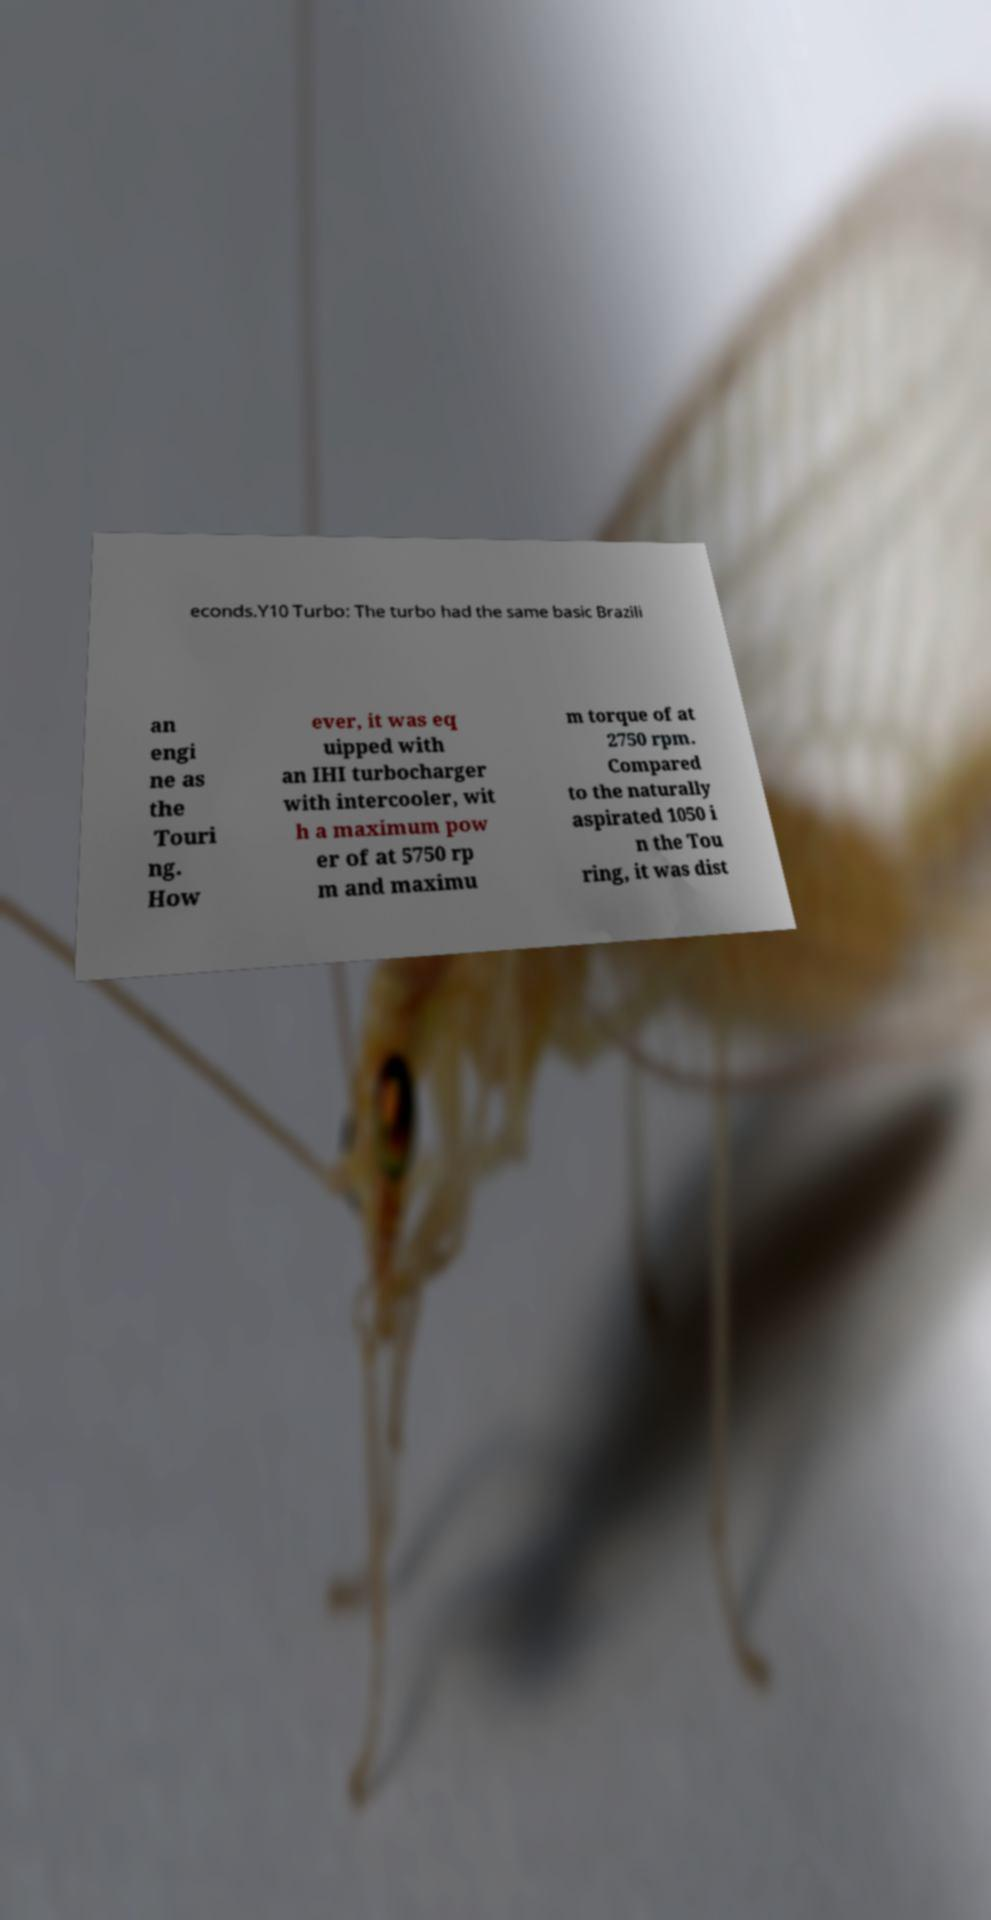Please read and relay the text visible in this image. What does it say? econds.Y10 Turbo: The turbo had the same basic Brazili an engi ne as the Touri ng. How ever, it was eq uipped with an IHI turbocharger with intercooler, wit h a maximum pow er of at 5750 rp m and maximu m torque of at 2750 rpm. Compared to the naturally aspirated 1050 i n the Tou ring, it was dist 